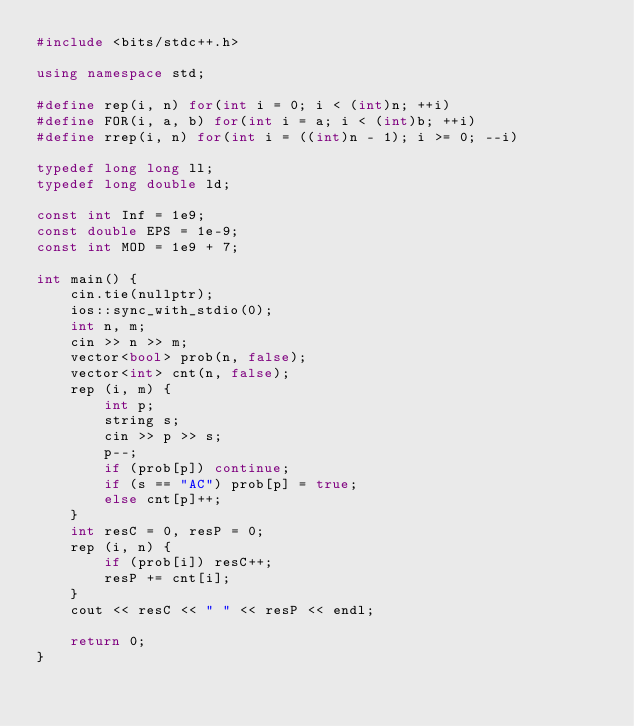Convert code to text. <code><loc_0><loc_0><loc_500><loc_500><_C++_>#include <bits/stdc++.h>

using namespace std;

#define rep(i, n) for(int i = 0; i < (int)n; ++i)
#define FOR(i, a, b) for(int i = a; i < (int)b; ++i)
#define rrep(i, n) for(int i = ((int)n - 1); i >= 0; --i)

typedef long long ll;
typedef long double ld;

const int Inf = 1e9;
const double EPS = 1e-9;
const int MOD = 1e9 + 7;

int main() {
    cin.tie(nullptr);
    ios::sync_with_stdio(0);
    int n, m;
    cin >> n >> m;
    vector<bool> prob(n, false);
    vector<int> cnt(n, false);
    rep (i, m) {
        int p;
        string s;
        cin >> p >> s;
        p--;
        if (prob[p]) continue;
        if (s == "AC") prob[p] = true;
        else cnt[p]++;
    }
    int resC = 0, resP = 0;
    rep (i, n) {
        if (prob[i]) resC++;
        resP += cnt[i];
    }
    cout << resC << " " << resP << endl;
    
    return 0;
}

</code> 